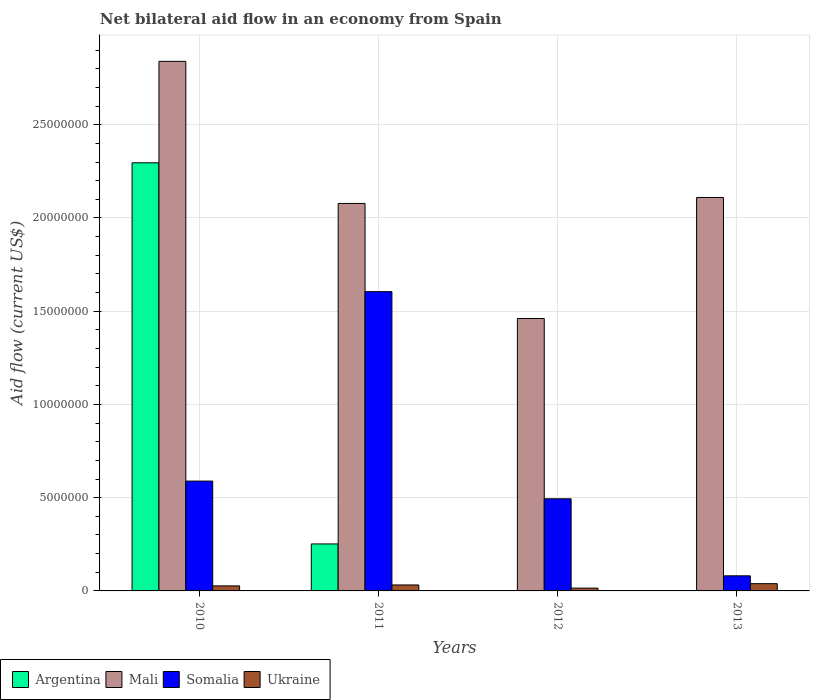Are the number of bars on each tick of the X-axis equal?
Provide a succinct answer. No. What is the net bilateral aid flow in Somalia in 2012?
Offer a very short reply. 4.94e+06. Across all years, what is the maximum net bilateral aid flow in Argentina?
Make the answer very short. 2.30e+07. Across all years, what is the minimum net bilateral aid flow in Mali?
Keep it short and to the point. 1.46e+07. What is the total net bilateral aid flow in Somalia in the graph?
Your answer should be compact. 2.77e+07. What is the difference between the net bilateral aid flow in Mali in 2010 and that in 2012?
Keep it short and to the point. 1.38e+07. What is the difference between the net bilateral aid flow in Somalia in 2012 and the net bilateral aid flow in Mali in 2013?
Keep it short and to the point. -1.62e+07. What is the average net bilateral aid flow in Somalia per year?
Offer a very short reply. 6.92e+06. In the year 2010, what is the difference between the net bilateral aid flow in Argentina and net bilateral aid flow in Mali?
Make the answer very short. -5.44e+06. What is the ratio of the net bilateral aid flow in Mali in 2010 to that in 2011?
Make the answer very short. 1.37. Is the difference between the net bilateral aid flow in Argentina in 2010 and 2011 greater than the difference between the net bilateral aid flow in Mali in 2010 and 2011?
Provide a succinct answer. Yes. What is the difference between the highest and the second highest net bilateral aid flow in Ukraine?
Your answer should be very brief. 7.00e+04. What is the difference between the highest and the lowest net bilateral aid flow in Mali?
Your answer should be very brief. 1.38e+07. Is the sum of the net bilateral aid flow in Mali in 2011 and 2012 greater than the maximum net bilateral aid flow in Ukraine across all years?
Keep it short and to the point. Yes. Is it the case that in every year, the sum of the net bilateral aid flow in Mali and net bilateral aid flow in Somalia is greater than the sum of net bilateral aid flow in Argentina and net bilateral aid flow in Ukraine?
Offer a very short reply. No. Are the values on the major ticks of Y-axis written in scientific E-notation?
Keep it short and to the point. No. Does the graph contain any zero values?
Your answer should be very brief. Yes. How many legend labels are there?
Provide a succinct answer. 4. What is the title of the graph?
Offer a very short reply. Net bilateral aid flow in an economy from Spain. Does "Thailand" appear as one of the legend labels in the graph?
Give a very brief answer. No. What is the label or title of the X-axis?
Provide a short and direct response. Years. What is the Aid flow (current US$) in Argentina in 2010?
Give a very brief answer. 2.30e+07. What is the Aid flow (current US$) in Mali in 2010?
Provide a succinct answer. 2.84e+07. What is the Aid flow (current US$) of Somalia in 2010?
Keep it short and to the point. 5.89e+06. What is the Aid flow (current US$) of Ukraine in 2010?
Your answer should be compact. 2.70e+05. What is the Aid flow (current US$) of Argentina in 2011?
Ensure brevity in your answer.  2.52e+06. What is the Aid flow (current US$) in Mali in 2011?
Provide a succinct answer. 2.08e+07. What is the Aid flow (current US$) in Somalia in 2011?
Provide a short and direct response. 1.60e+07. What is the Aid flow (current US$) of Argentina in 2012?
Keep it short and to the point. 0. What is the Aid flow (current US$) in Mali in 2012?
Offer a terse response. 1.46e+07. What is the Aid flow (current US$) in Somalia in 2012?
Your response must be concise. 4.94e+06. What is the Aid flow (current US$) of Mali in 2013?
Your response must be concise. 2.11e+07. What is the Aid flow (current US$) in Somalia in 2013?
Keep it short and to the point. 8.10e+05. What is the Aid flow (current US$) of Ukraine in 2013?
Provide a succinct answer. 3.90e+05. Across all years, what is the maximum Aid flow (current US$) of Argentina?
Your response must be concise. 2.30e+07. Across all years, what is the maximum Aid flow (current US$) of Mali?
Give a very brief answer. 2.84e+07. Across all years, what is the maximum Aid flow (current US$) of Somalia?
Offer a terse response. 1.60e+07. Across all years, what is the minimum Aid flow (current US$) in Mali?
Your response must be concise. 1.46e+07. Across all years, what is the minimum Aid flow (current US$) of Somalia?
Offer a very short reply. 8.10e+05. Across all years, what is the minimum Aid flow (current US$) of Ukraine?
Offer a terse response. 1.50e+05. What is the total Aid flow (current US$) in Argentina in the graph?
Give a very brief answer. 2.55e+07. What is the total Aid flow (current US$) in Mali in the graph?
Give a very brief answer. 8.49e+07. What is the total Aid flow (current US$) of Somalia in the graph?
Your answer should be compact. 2.77e+07. What is the total Aid flow (current US$) of Ukraine in the graph?
Make the answer very short. 1.13e+06. What is the difference between the Aid flow (current US$) of Argentina in 2010 and that in 2011?
Your answer should be very brief. 2.04e+07. What is the difference between the Aid flow (current US$) of Mali in 2010 and that in 2011?
Ensure brevity in your answer.  7.62e+06. What is the difference between the Aid flow (current US$) of Somalia in 2010 and that in 2011?
Provide a succinct answer. -1.02e+07. What is the difference between the Aid flow (current US$) of Ukraine in 2010 and that in 2011?
Provide a succinct answer. -5.00e+04. What is the difference between the Aid flow (current US$) of Mali in 2010 and that in 2012?
Keep it short and to the point. 1.38e+07. What is the difference between the Aid flow (current US$) of Somalia in 2010 and that in 2012?
Offer a very short reply. 9.50e+05. What is the difference between the Aid flow (current US$) in Mali in 2010 and that in 2013?
Offer a very short reply. 7.30e+06. What is the difference between the Aid flow (current US$) in Somalia in 2010 and that in 2013?
Provide a short and direct response. 5.08e+06. What is the difference between the Aid flow (current US$) in Ukraine in 2010 and that in 2013?
Your answer should be very brief. -1.20e+05. What is the difference between the Aid flow (current US$) of Mali in 2011 and that in 2012?
Your response must be concise. 6.17e+06. What is the difference between the Aid flow (current US$) of Somalia in 2011 and that in 2012?
Your response must be concise. 1.11e+07. What is the difference between the Aid flow (current US$) in Mali in 2011 and that in 2013?
Your answer should be compact. -3.20e+05. What is the difference between the Aid flow (current US$) of Somalia in 2011 and that in 2013?
Your answer should be very brief. 1.52e+07. What is the difference between the Aid flow (current US$) in Mali in 2012 and that in 2013?
Make the answer very short. -6.49e+06. What is the difference between the Aid flow (current US$) in Somalia in 2012 and that in 2013?
Your answer should be compact. 4.13e+06. What is the difference between the Aid flow (current US$) of Argentina in 2010 and the Aid flow (current US$) of Mali in 2011?
Ensure brevity in your answer.  2.18e+06. What is the difference between the Aid flow (current US$) of Argentina in 2010 and the Aid flow (current US$) of Somalia in 2011?
Your answer should be compact. 6.91e+06. What is the difference between the Aid flow (current US$) in Argentina in 2010 and the Aid flow (current US$) in Ukraine in 2011?
Ensure brevity in your answer.  2.26e+07. What is the difference between the Aid flow (current US$) in Mali in 2010 and the Aid flow (current US$) in Somalia in 2011?
Offer a terse response. 1.24e+07. What is the difference between the Aid flow (current US$) of Mali in 2010 and the Aid flow (current US$) of Ukraine in 2011?
Your response must be concise. 2.81e+07. What is the difference between the Aid flow (current US$) in Somalia in 2010 and the Aid flow (current US$) in Ukraine in 2011?
Offer a terse response. 5.57e+06. What is the difference between the Aid flow (current US$) of Argentina in 2010 and the Aid flow (current US$) of Mali in 2012?
Provide a succinct answer. 8.35e+06. What is the difference between the Aid flow (current US$) of Argentina in 2010 and the Aid flow (current US$) of Somalia in 2012?
Provide a short and direct response. 1.80e+07. What is the difference between the Aid flow (current US$) in Argentina in 2010 and the Aid flow (current US$) in Ukraine in 2012?
Ensure brevity in your answer.  2.28e+07. What is the difference between the Aid flow (current US$) of Mali in 2010 and the Aid flow (current US$) of Somalia in 2012?
Your answer should be compact. 2.35e+07. What is the difference between the Aid flow (current US$) in Mali in 2010 and the Aid flow (current US$) in Ukraine in 2012?
Your response must be concise. 2.82e+07. What is the difference between the Aid flow (current US$) in Somalia in 2010 and the Aid flow (current US$) in Ukraine in 2012?
Your response must be concise. 5.74e+06. What is the difference between the Aid flow (current US$) in Argentina in 2010 and the Aid flow (current US$) in Mali in 2013?
Ensure brevity in your answer.  1.86e+06. What is the difference between the Aid flow (current US$) of Argentina in 2010 and the Aid flow (current US$) of Somalia in 2013?
Give a very brief answer. 2.22e+07. What is the difference between the Aid flow (current US$) in Argentina in 2010 and the Aid flow (current US$) in Ukraine in 2013?
Offer a terse response. 2.26e+07. What is the difference between the Aid flow (current US$) in Mali in 2010 and the Aid flow (current US$) in Somalia in 2013?
Offer a very short reply. 2.76e+07. What is the difference between the Aid flow (current US$) in Mali in 2010 and the Aid flow (current US$) in Ukraine in 2013?
Provide a short and direct response. 2.80e+07. What is the difference between the Aid flow (current US$) of Somalia in 2010 and the Aid flow (current US$) of Ukraine in 2013?
Ensure brevity in your answer.  5.50e+06. What is the difference between the Aid flow (current US$) of Argentina in 2011 and the Aid flow (current US$) of Mali in 2012?
Your answer should be very brief. -1.21e+07. What is the difference between the Aid flow (current US$) in Argentina in 2011 and the Aid flow (current US$) in Somalia in 2012?
Your answer should be compact. -2.42e+06. What is the difference between the Aid flow (current US$) in Argentina in 2011 and the Aid flow (current US$) in Ukraine in 2012?
Give a very brief answer. 2.37e+06. What is the difference between the Aid flow (current US$) in Mali in 2011 and the Aid flow (current US$) in Somalia in 2012?
Your response must be concise. 1.58e+07. What is the difference between the Aid flow (current US$) in Mali in 2011 and the Aid flow (current US$) in Ukraine in 2012?
Offer a terse response. 2.06e+07. What is the difference between the Aid flow (current US$) in Somalia in 2011 and the Aid flow (current US$) in Ukraine in 2012?
Your answer should be compact. 1.59e+07. What is the difference between the Aid flow (current US$) of Argentina in 2011 and the Aid flow (current US$) of Mali in 2013?
Give a very brief answer. -1.86e+07. What is the difference between the Aid flow (current US$) of Argentina in 2011 and the Aid flow (current US$) of Somalia in 2013?
Give a very brief answer. 1.71e+06. What is the difference between the Aid flow (current US$) in Argentina in 2011 and the Aid flow (current US$) in Ukraine in 2013?
Your response must be concise. 2.13e+06. What is the difference between the Aid flow (current US$) in Mali in 2011 and the Aid flow (current US$) in Somalia in 2013?
Ensure brevity in your answer.  2.00e+07. What is the difference between the Aid flow (current US$) of Mali in 2011 and the Aid flow (current US$) of Ukraine in 2013?
Your response must be concise. 2.04e+07. What is the difference between the Aid flow (current US$) in Somalia in 2011 and the Aid flow (current US$) in Ukraine in 2013?
Ensure brevity in your answer.  1.57e+07. What is the difference between the Aid flow (current US$) in Mali in 2012 and the Aid flow (current US$) in Somalia in 2013?
Offer a terse response. 1.38e+07. What is the difference between the Aid flow (current US$) of Mali in 2012 and the Aid flow (current US$) of Ukraine in 2013?
Your response must be concise. 1.42e+07. What is the difference between the Aid flow (current US$) of Somalia in 2012 and the Aid flow (current US$) of Ukraine in 2013?
Your response must be concise. 4.55e+06. What is the average Aid flow (current US$) in Argentina per year?
Your response must be concise. 6.37e+06. What is the average Aid flow (current US$) of Mali per year?
Provide a succinct answer. 2.12e+07. What is the average Aid flow (current US$) of Somalia per year?
Your answer should be very brief. 6.92e+06. What is the average Aid flow (current US$) in Ukraine per year?
Provide a short and direct response. 2.82e+05. In the year 2010, what is the difference between the Aid flow (current US$) in Argentina and Aid flow (current US$) in Mali?
Your response must be concise. -5.44e+06. In the year 2010, what is the difference between the Aid flow (current US$) in Argentina and Aid flow (current US$) in Somalia?
Provide a short and direct response. 1.71e+07. In the year 2010, what is the difference between the Aid flow (current US$) of Argentina and Aid flow (current US$) of Ukraine?
Give a very brief answer. 2.27e+07. In the year 2010, what is the difference between the Aid flow (current US$) of Mali and Aid flow (current US$) of Somalia?
Give a very brief answer. 2.25e+07. In the year 2010, what is the difference between the Aid flow (current US$) of Mali and Aid flow (current US$) of Ukraine?
Provide a succinct answer. 2.81e+07. In the year 2010, what is the difference between the Aid flow (current US$) of Somalia and Aid flow (current US$) of Ukraine?
Provide a short and direct response. 5.62e+06. In the year 2011, what is the difference between the Aid flow (current US$) of Argentina and Aid flow (current US$) of Mali?
Provide a short and direct response. -1.83e+07. In the year 2011, what is the difference between the Aid flow (current US$) in Argentina and Aid flow (current US$) in Somalia?
Offer a very short reply. -1.35e+07. In the year 2011, what is the difference between the Aid flow (current US$) in Argentina and Aid flow (current US$) in Ukraine?
Keep it short and to the point. 2.20e+06. In the year 2011, what is the difference between the Aid flow (current US$) in Mali and Aid flow (current US$) in Somalia?
Ensure brevity in your answer.  4.73e+06. In the year 2011, what is the difference between the Aid flow (current US$) of Mali and Aid flow (current US$) of Ukraine?
Your answer should be very brief. 2.05e+07. In the year 2011, what is the difference between the Aid flow (current US$) in Somalia and Aid flow (current US$) in Ukraine?
Offer a very short reply. 1.57e+07. In the year 2012, what is the difference between the Aid flow (current US$) in Mali and Aid flow (current US$) in Somalia?
Your answer should be very brief. 9.67e+06. In the year 2012, what is the difference between the Aid flow (current US$) of Mali and Aid flow (current US$) of Ukraine?
Ensure brevity in your answer.  1.45e+07. In the year 2012, what is the difference between the Aid flow (current US$) in Somalia and Aid flow (current US$) in Ukraine?
Offer a terse response. 4.79e+06. In the year 2013, what is the difference between the Aid flow (current US$) in Mali and Aid flow (current US$) in Somalia?
Provide a short and direct response. 2.03e+07. In the year 2013, what is the difference between the Aid flow (current US$) of Mali and Aid flow (current US$) of Ukraine?
Keep it short and to the point. 2.07e+07. What is the ratio of the Aid flow (current US$) of Argentina in 2010 to that in 2011?
Make the answer very short. 9.11. What is the ratio of the Aid flow (current US$) of Mali in 2010 to that in 2011?
Offer a very short reply. 1.37. What is the ratio of the Aid flow (current US$) in Somalia in 2010 to that in 2011?
Your response must be concise. 0.37. What is the ratio of the Aid flow (current US$) of Ukraine in 2010 to that in 2011?
Keep it short and to the point. 0.84. What is the ratio of the Aid flow (current US$) of Mali in 2010 to that in 2012?
Provide a succinct answer. 1.94. What is the ratio of the Aid flow (current US$) in Somalia in 2010 to that in 2012?
Make the answer very short. 1.19. What is the ratio of the Aid flow (current US$) of Ukraine in 2010 to that in 2012?
Give a very brief answer. 1.8. What is the ratio of the Aid flow (current US$) of Mali in 2010 to that in 2013?
Provide a short and direct response. 1.35. What is the ratio of the Aid flow (current US$) in Somalia in 2010 to that in 2013?
Your answer should be very brief. 7.27. What is the ratio of the Aid flow (current US$) of Ukraine in 2010 to that in 2013?
Provide a short and direct response. 0.69. What is the ratio of the Aid flow (current US$) in Mali in 2011 to that in 2012?
Provide a short and direct response. 1.42. What is the ratio of the Aid flow (current US$) in Somalia in 2011 to that in 2012?
Offer a terse response. 3.25. What is the ratio of the Aid flow (current US$) of Ukraine in 2011 to that in 2012?
Your answer should be compact. 2.13. What is the ratio of the Aid flow (current US$) of Mali in 2011 to that in 2013?
Your answer should be compact. 0.98. What is the ratio of the Aid flow (current US$) in Somalia in 2011 to that in 2013?
Offer a very short reply. 19.81. What is the ratio of the Aid flow (current US$) in Ukraine in 2011 to that in 2013?
Keep it short and to the point. 0.82. What is the ratio of the Aid flow (current US$) in Mali in 2012 to that in 2013?
Your answer should be very brief. 0.69. What is the ratio of the Aid flow (current US$) in Somalia in 2012 to that in 2013?
Your response must be concise. 6.1. What is the ratio of the Aid flow (current US$) in Ukraine in 2012 to that in 2013?
Your answer should be compact. 0.38. What is the difference between the highest and the second highest Aid flow (current US$) of Mali?
Your answer should be very brief. 7.30e+06. What is the difference between the highest and the second highest Aid flow (current US$) of Somalia?
Your answer should be very brief. 1.02e+07. What is the difference between the highest and the second highest Aid flow (current US$) in Ukraine?
Your answer should be very brief. 7.00e+04. What is the difference between the highest and the lowest Aid flow (current US$) of Argentina?
Ensure brevity in your answer.  2.30e+07. What is the difference between the highest and the lowest Aid flow (current US$) of Mali?
Give a very brief answer. 1.38e+07. What is the difference between the highest and the lowest Aid flow (current US$) of Somalia?
Give a very brief answer. 1.52e+07. What is the difference between the highest and the lowest Aid flow (current US$) of Ukraine?
Provide a succinct answer. 2.40e+05. 